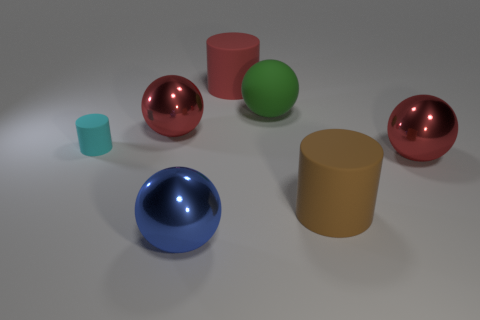There is a green object that is the same shape as the blue shiny object; what material is it?
Your response must be concise. Rubber. There is a ball on the left side of the blue shiny thing; does it have the same size as the large blue sphere?
Provide a succinct answer. Yes. There is a cyan matte cylinder; how many tiny things are left of it?
Your response must be concise. 0. Is the number of red shiny spheres to the right of the small cyan cylinder less than the number of objects on the left side of the big green ball?
Provide a short and direct response. Yes. What number of large red cylinders are there?
Your response must be concise. 1. There is a big metallic thing that is in front of the brown object; what color is it?
Provide a short and direct response. Blue. The red matte thing has what size?
Keep it short and to the point. Large. What color is the large cylinder that is on the right side of the big rubber thing that is on the left side of the matte sphere?
Keep it short and to the point. Brown. Is there anything else that has the same size as the cyan thing?
Provide a short and direct response. No. There is a matte object that is to the left of the big blue sphere; is its shape the same as the brown rubber thing?
Provide a short and direct response. Yes. 